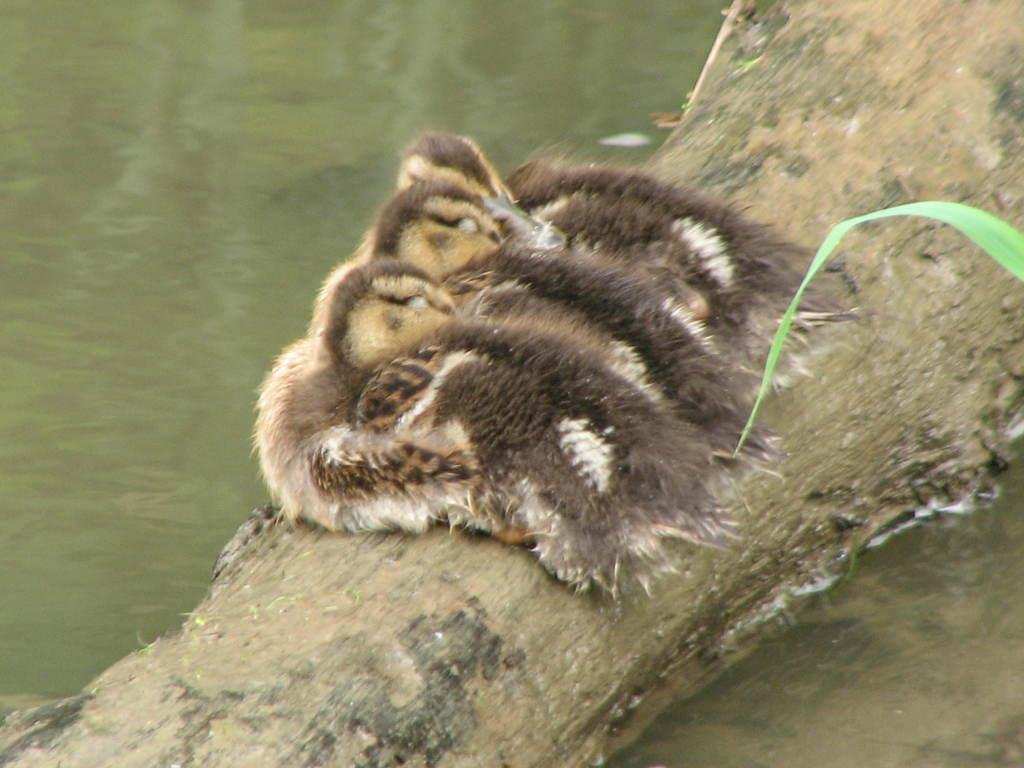What animals are on the wooden platform in the image? There are birds on a wooden platform in the image. What can be seen in the background of the image? Water is visible in the image. What type of vegetation is present in the image? Leaves are present in the image. What type of rod can be seen holding the grapes in the image? There is no rod or grapes present in the image; it features birds on a wooden platform and water in the background. Can you describe the flight pattern of the birds in the image? The image does not show the birds in flight, so their flight pattern cannot be determined. 